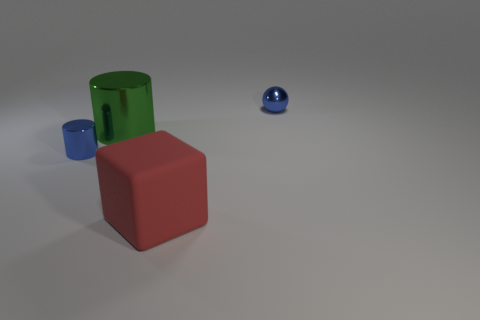Add 1 small blue metal spheres. How many objects exist? 5 Subtract all blocks. How many objects are left? 3 Add 4 big green shiny things. How many big green shiny things exist? 5 Subtract 0 cyan balls. How many objects are left? 4 Subtract all tiny objects. Subtract all large matte things. How many objects are left? 1 Add 1 shiny objects. How many shiny objects are left? 4 